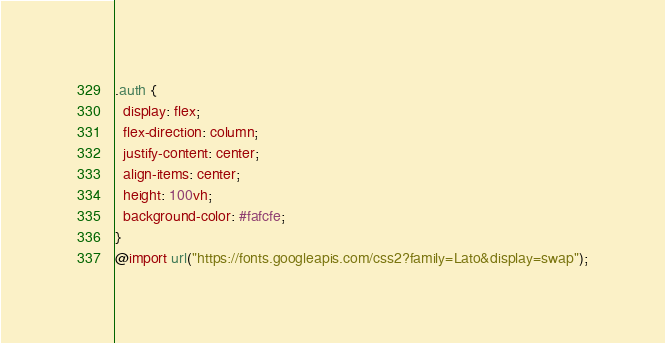<code> <loc_0><loc_0><loc_500><loc_500><_CSS_>.auth {
  display: flex;
  flex-direction: column;
  justify-content: center;
  align-items: center;
  height: 100vh;
  background-color: #fafcfe;
}
@import url("https://fonts.googleapis.com/css2?family=Lato&display=swap");
</code> 